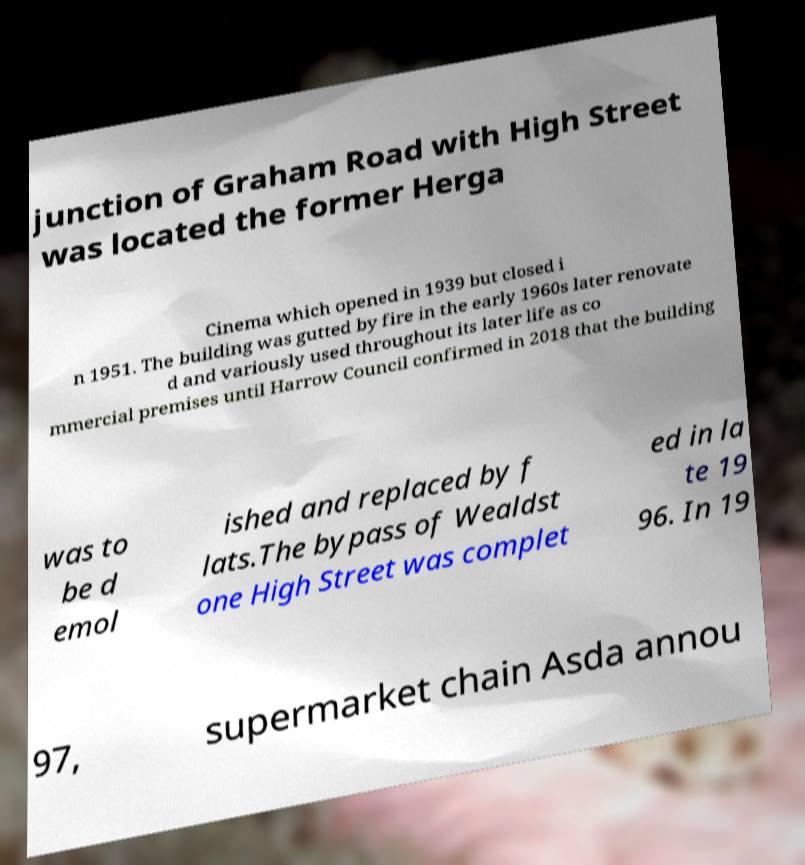Please identify and transcribe the text found in this image. junction of Graham Road with High Street was located the former Herga Cinema which opened in 1939 but closed i n 1951. The building was gutted by fire in the early 1960s later renovate d and variously used throughout its later life as co mmercial premises until Harrow Council confirmed in 2018 that the building was to be d emol ished and replaced by f lats.The bypass of Wealdst one High Street was complet ed in la te 19 96. In 19 97, supermarket chain Asda annou 